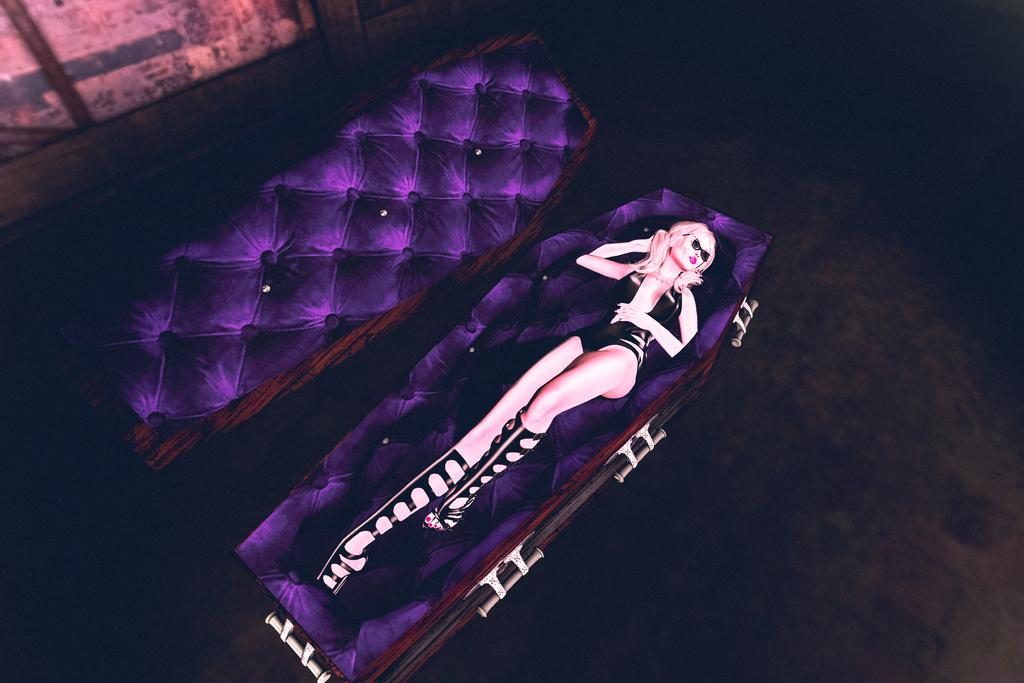Who is the main subject in the image? There is a woman in the image. What is the woman wearing? The woman is wearing a black dress. What is the woman's position in the image? The woman is laying inside a coffin. What type of grape can be seen in the woman's hand in the image? There is no grape present in the image; the woman is laying inside a coffin and not holding any objects. 